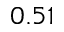<formula> <loc_0><loc_0><loc_500><loc_500>0 . 5 1</formula> 